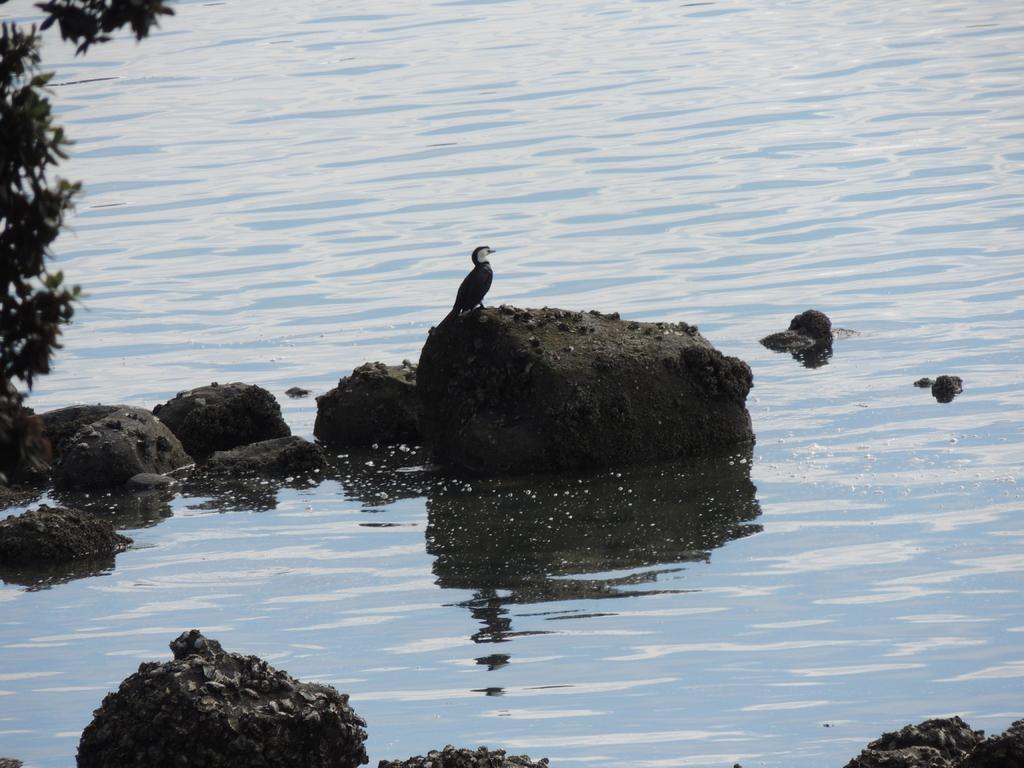How would you summarize this image in a sentence or two? In this image a bird is standing on the rock which is on water. Left side there are few leaves to the branches. Bottom of image there are few rocks. 